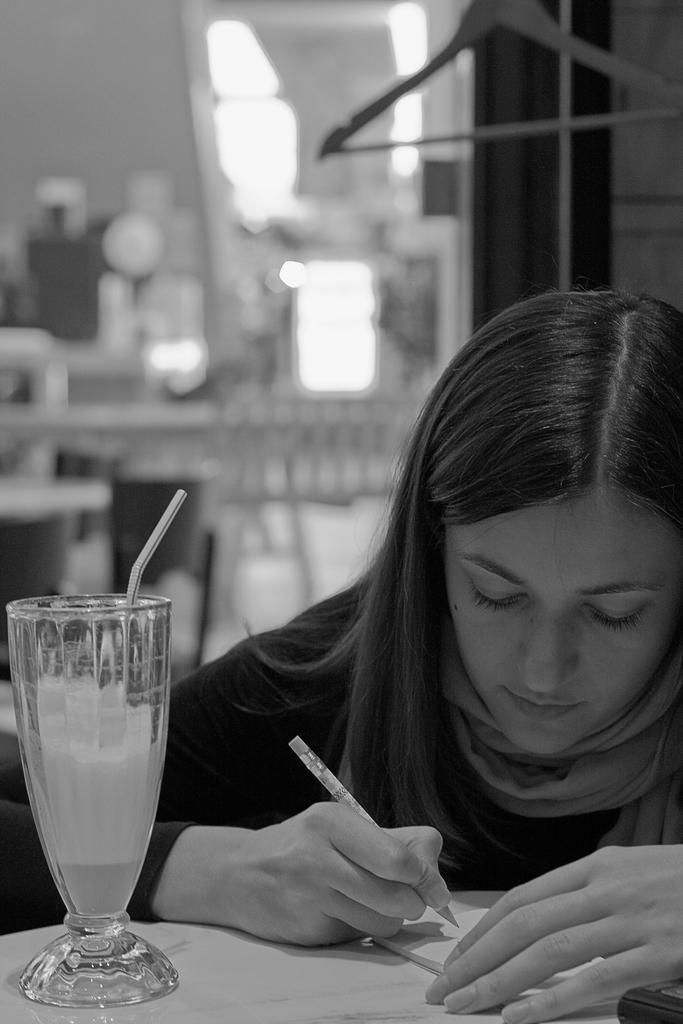Can you describe this image briefly? This is a black and white picture. Background is very blurry. Here we can see one women sitting and holding a pen in her hand and there is a book on the table and also a juice glass with straw. 